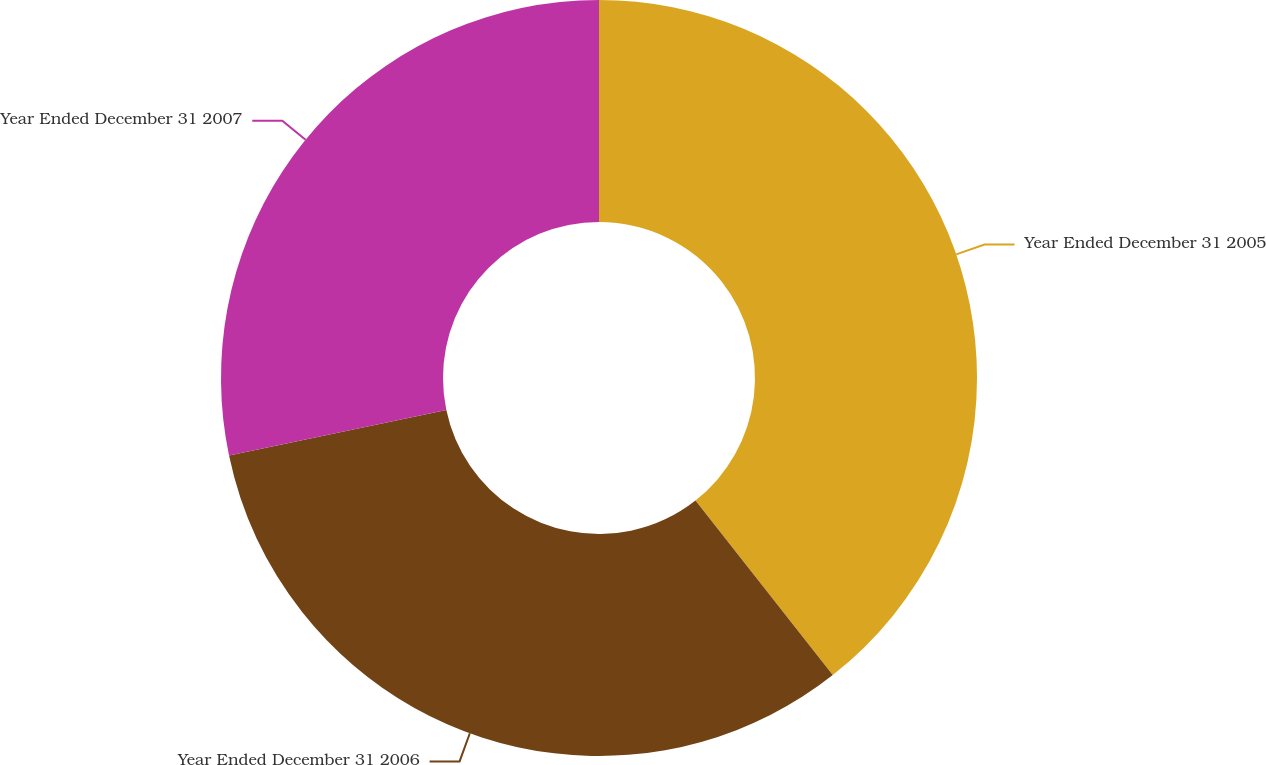<chart> <loc_0><loc_0><loc_500><loc_500><pie_chart><fcel>Year Ended December 31 2005<fcel>Year Ended December 31 2006<fcel>Year Ended December 31 2007<nl><fcel>39.39%<fcel>32.32%<fcel>28.29%<nl></chart> 